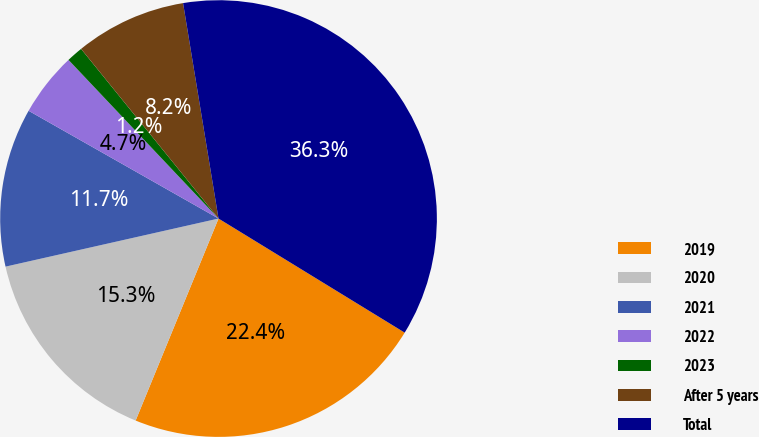<chart> <loc_0><loc_0><loc_500><loc_500><pie_chart><fcel>2019<fcel>2020<fcel>2021<fcel>2022<fcel>2023<fcel>After 5 years<fcel>Total<nl><fcel>22.45%<fcel>15.27%<fcel>11.75%<fcel>4.73%<fcel>1.22%<fcel>8.24%<fcel>36.35%<nl></chart> 